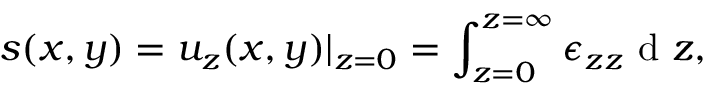Convert formula to latex. <formula><loc_0><loc_0><loc_500><loc_500>s ( x , y ) = u _ { z } ( x , y ) | _ { z = 0 } = \int _ { z = 0 } ^ { z = \infty } \epsilon _ { z z } d z ,</formula> 